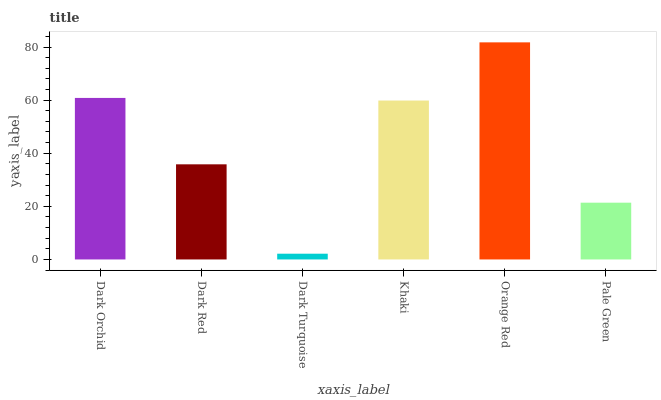Is Dark Turquoise the minimum?
Answer yes or no. Yes. Is Orange Red the maximum?
Answer yes or no. Yes. Is Dark Red the minimum?
Answer yes or no. No. Is Dark Red the maximum?
Answer yes or no. No. Is Dark Orchid greater than Dark Red?
Answer yes or no. Yes. Is Dark Red less than Dark Orchid?
Answer yes or no. Yes. Is Dark Red greater than Dark Orchid?
Answer yes or no. No. Is Dark Orchid less than Dark Red?
Answer yes or no. No. Is Khaki the high median?
Answer yes or no. Yes. Is Dark Red the low median?
Answer yes or no. Yes. Is Dark Orchid the high median?
Answer yes or no. No. Is Dark Orchid the low median?
Answer yes or no. No. 